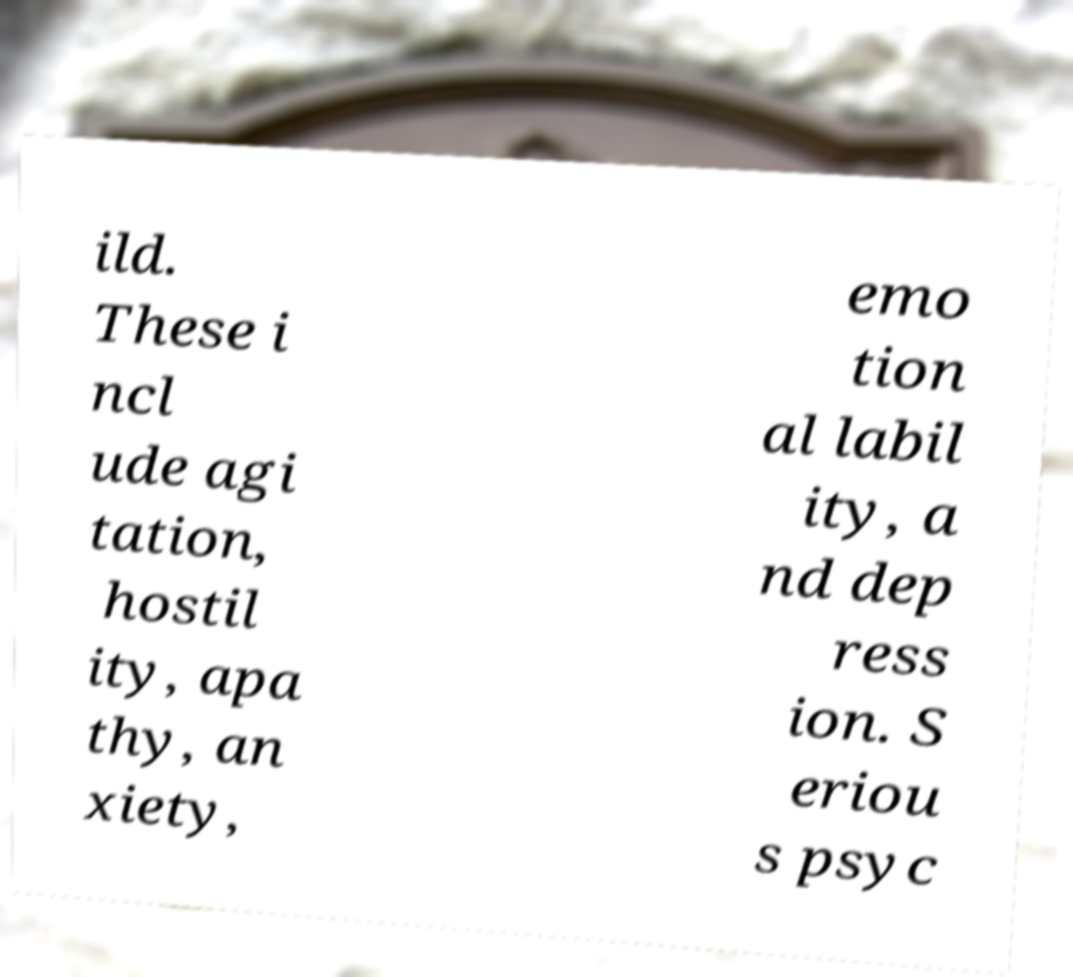Please identify and transcribe the text found in this image. ild. These i ncl ude agi tation, hostil ity, apa thy, an xiety, emo tion al labil ity, a nd dep ress ion. S eriou s psyc 